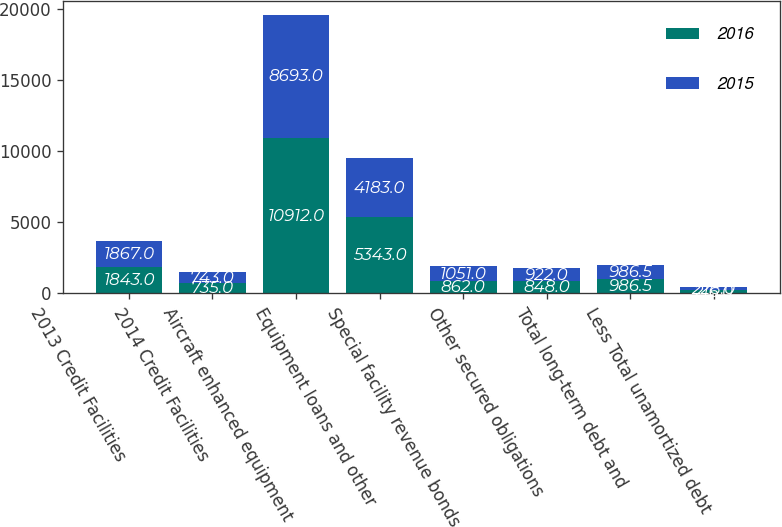<chart> <loc_0><loc_0><loc_500><loc_500><stacked_bar_chart><ecel><fcel>2013 Credit Facilities<fcel>2014 Credit Facilities<fcel>Aircraft enhanced equipment<fcel>Equipment loans and other<fcel>Special facility revenue bonds<fcel>Other secured obligations<fcel>Total long-term debt and<fcel>Less Total unamortized debt<nl><fcel>2016<fcel>1843<fcel>735<fcel>10912<fcel>5343<fcel>862<fcel>848<fcel>986.5<fcel>216<nl><fcel>2015<fcel>1867<fcel>743<fcel>8693<fcel>4183<fcel>1051<fcel>922<fcel>986.5<fcel>228<nl></chart> 